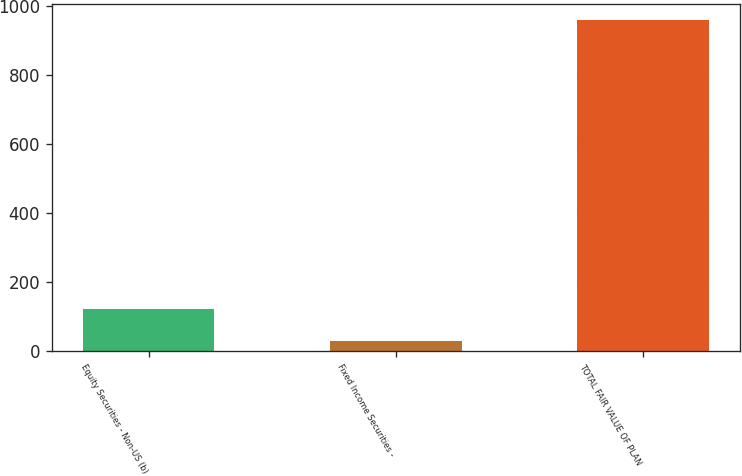<chart> <loc_0><loc_0><loc_500><loc_500><bar_chart><fcel>Equity Securities - Non-US (b)<fcel>Fixed Income Securities -<fcel>TOTAL FAIR VALUE OF PLAN<nl><fcel>123<fcel>30<fcel>960<nl></chart> 